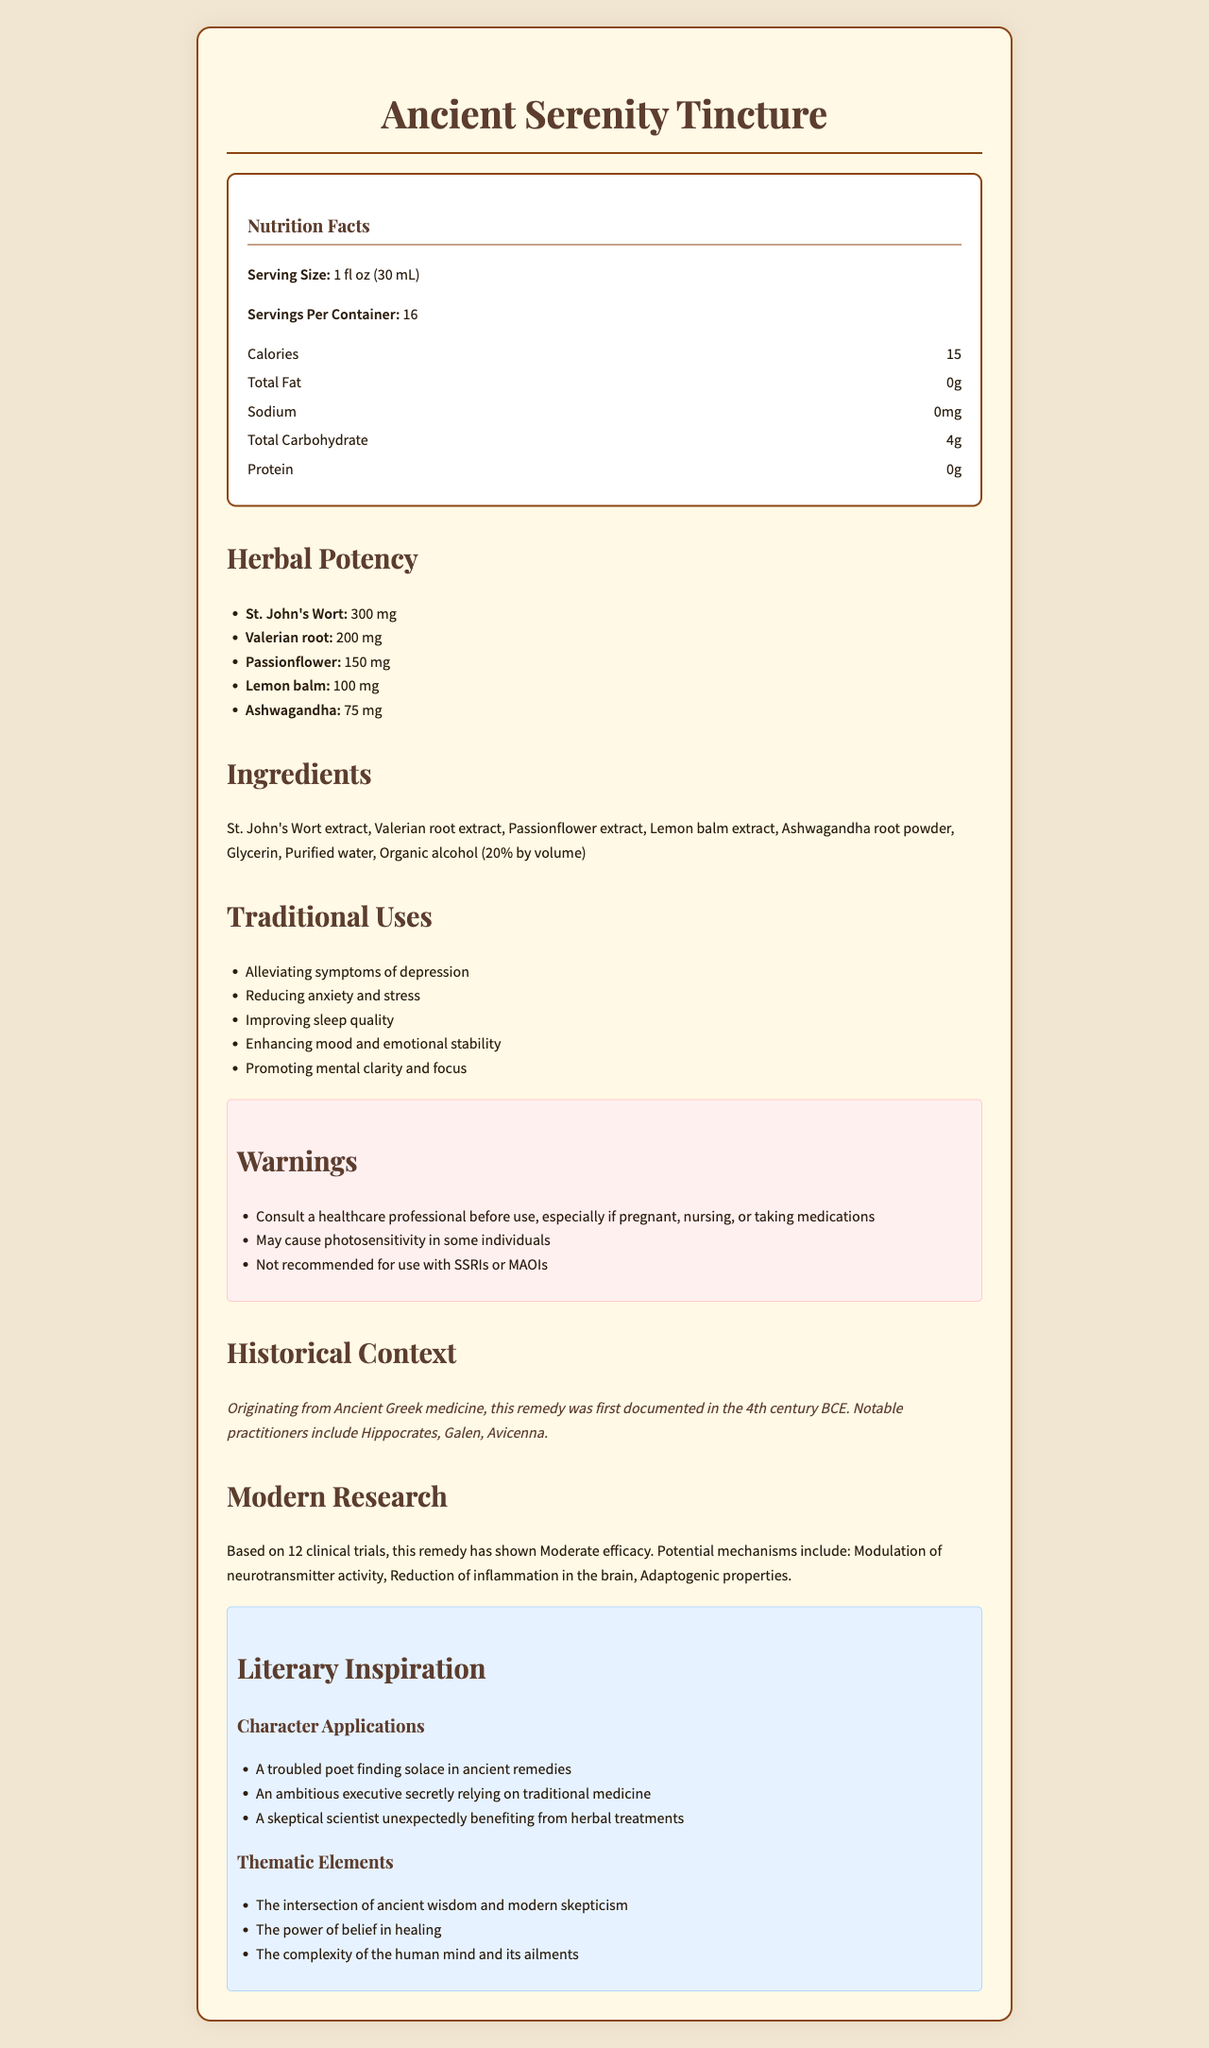what is the product name? The product name is clearly stated at the top of the document.
Answer: Ancient Serenity Tincture how many servings are there per container? The document mentions that there are 16 servings per container under the Nutrition Facts section.
Answer: 16 what is the primary focus of the traditional uses of this tincture? The Traditional Uses section lists these specific benefits.
Answer: Alleviating symptoms of depression, reducing anxiety and stress, improving sleep quality, enhancing mood and emotional stability, promoting mental clarity and focus name one of the influential practitioners mentioned in the historical context. The Historical Context section lists influential practitioners, including Hippocrates.
Answer: Hippocrates what are the calories per serving for the Ancient Serenity Tincture? The Nutrition Facts section notes the number of calories per serving.
Answer: 15 calories what are the main ingredients included in the Ancient Serenity Tincture? The Ingredients section lists these components.
Answer: St. John's Wort extract, Valerian root extract, Passionflower extract, Lemon balm extract, Ashwagandha root powder, Glycerin, Purified water, Organic alcohol (20% by volume) which of the following herbs has the highest potency in the tincture? I. Lemon balm II. St. John’s Wort III. Valerian root IV. Passionflower The Herbal Potency section shows that St. John's Wort has 300 mg, which is the highest amount compared to the other herbs listed.
Answer: II. St. John's Wort which warnings are included for this remedy? A. Not recommended for children under 12 B. Consult a healthcare professional if taking medications C. May cause nausea and dizziness D. Contains peanuts The warnings section specifically mentions consulting a healthcare professional if taking medications.
Answer: B does the tincture recommend usage with SSRIs or MAOIs? The Warnings section clearly states that it is not recommended for use with SSRIs or MAOIs.
Answer: No summarize the main idea of the document. The document comprehensively covers various aspects of the Ancient Serenity Tincture, emphasizing its traditional uses for mental health, alongside historical and modern perspectives, as well as literary applications.
Answer: The document provides detailed information about an herbal remedy called Ancient Serenity Tincture, including its nutrition facts, ingredients, traditional uses, warnings, historical context, modern research, and literary inspiration for character and thematic development. how many clinical trials have been conducted on this remedy? The Modern Research section states that there have been 12 clinical trials.
Answer: 12 what is not provided by this document? The document does not mention any specific age recommendation for the usage of the tincture.
Answer: The specific age group for which the tincture is recommended. 